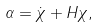Convert formula to latex. <formula><loc_0><loc_0><loc_500><loc_500>\alpha = \dot { \chi } + H \chi ,</formula> 